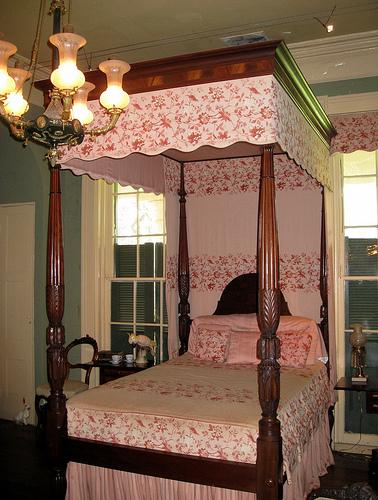What is the general sentiment or feeling that the image conveys? The image conveys a cozy, warm, and nostalgic feeling, with the combination of vintage furniture and the pink and red color scheme. How many decorative items can be seen in the room, and what are they? There are six decorative items: a bunny-shaped door stop, a ceramic knick-knack on a table, a small glass white cockatoo, pink and flowered designed pillows, decorative throw pillows on the bed, and a pink and red canopy. Please provide a brief description of the room's furnishings and decor. The room has a wooden four-post bed with canopy, some pillows, a chair, a wooden chair, a bedside table lamp, a chandelier light, and some windows. What type of bed is displayed in the image, and what does it feature? The image shows a wooden four-post bed with a pink and red canopy, ornate headboard, and a pink bedspread set featuring darker pink flowers. What types of windows can be observed in the image, and what specific details do they have? There are two windows: one with white window panes, and another that is plain. Both have wooden frames and are rectangular in shape. Explain the color scheme and overall style of the bedroom. The bedroom has a pink and red color scheme, featuring a mix of old-fashioned, ornate, and floral designs, contributing to a cozy, vintage ambiance. Describe the lighting fixtures present in the image. There is a chandelier light and an old-fashioned chandelier hanging from the ceiling, a lamp and an old hurricane lamp on bedside tables, and a bedside table lamp. Can you tell me how many pillows are present on the bed and their design? There are some pillows on the bed, including pink and flowered designed pillows and three pink and red pillows, making six pillows in total. Identify the objects placed on the bedside table and describe each one. There are two tea cups in saucers and a small old-style lamp placed on the bedside table. Describe the details of the different posts of the four-post bed. The four-post bed has carved wooden posts, with at least one featuring an ornate design. 